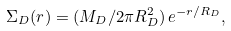Convert formula to latex. <formula><loc_0><loc_0><loc_500><loc_500>\Sigma _ { D } ( r ) = ( M _ { D } / 2 \pi R _ { D } ^ { 2 } ) \, e ^ { - r / R _ { D } } ,</formula> 